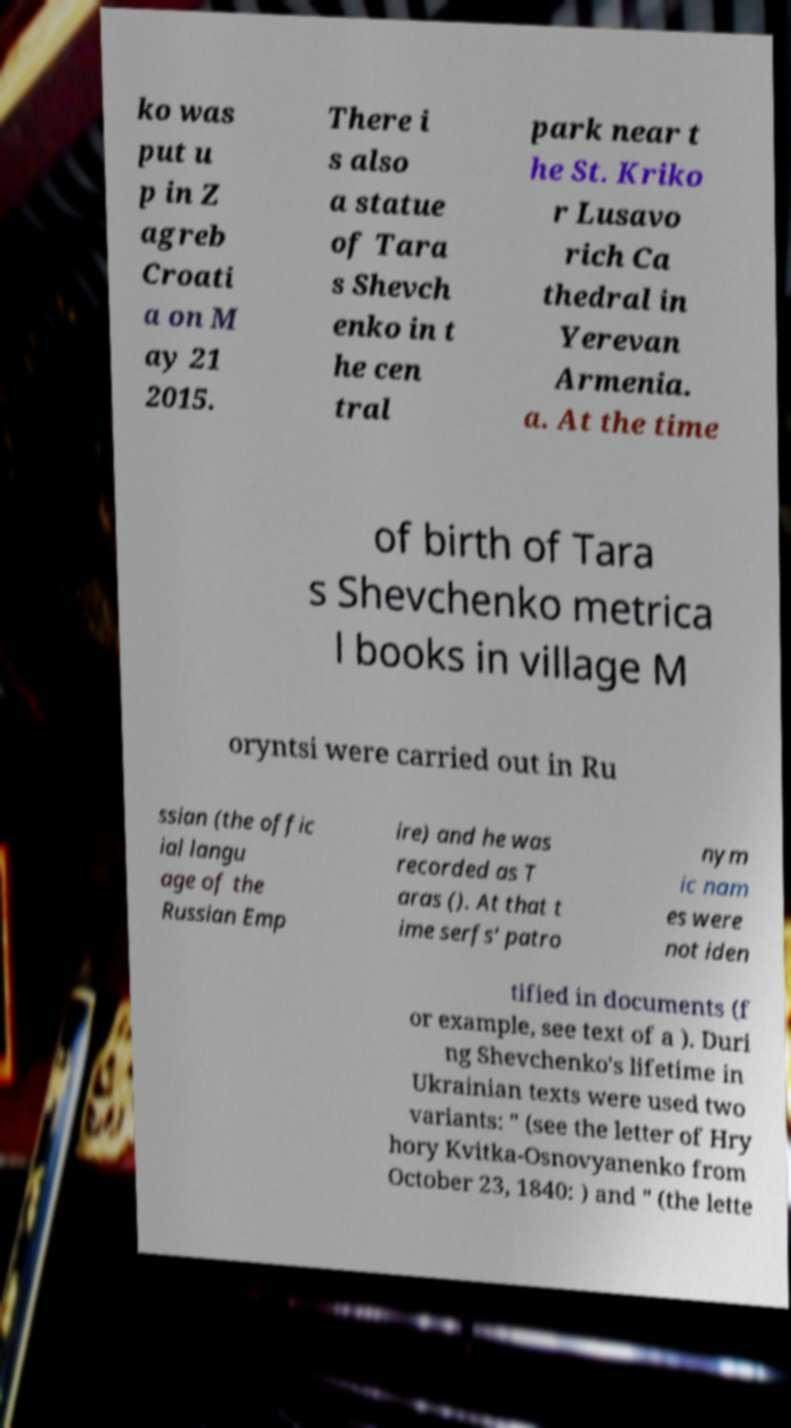Please identify and transcribe the text found in this image. ko was put u p in Z agreb Croati a on M ay 21 2015. There i s also a statue of Tara s Shevch enko in t he cen tral park near t he St. Kriko r Lusavo rich Ca thedral in Yerevan Armenia. a. At the time of birth of Tara s Shevchenko metrica l books in village M oryntsi were carried out in Ru ssian (the offic ial langu age of the Russian Emp ire) and he was recorded as T aras (). At that t ime serfs' patro nym ic nam es were not iden tified in documents (f or example, see text of a ). Duri ng Shevchenko's lifetime in Ukrainian texts were used two variants: " (see the letter of Hry hory Kvitka-Osnovyanenko from October 23, 1840: ) and " (the lette 